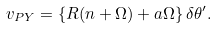<formula> <loc_0><loc_0><loc_500><loc_500>v _ { P Y } = \left \{ R ( n + \Omega ) + a \Omega \right \} \delta \theta ^ { \prime } .</formula> 